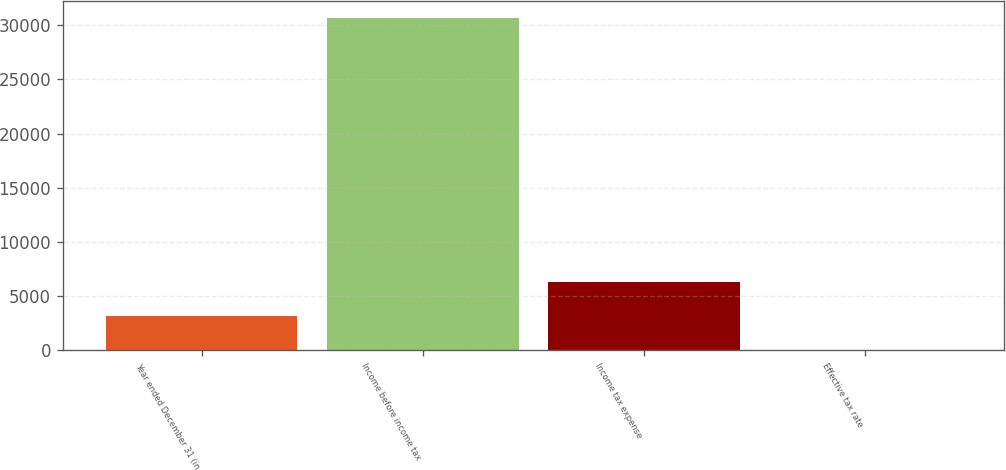Convert chart to OTSL. <chart><loc_0><loc_0><loc_500><loc_500><bar_chart><fcel>Year ended December 31 (in<fcel>Income before income tax<fcel>Income tax expense<fcel>Effective tax rate<nl><fcel>3088.56<fcel>30702<fcel>6260<fcel>20.4<nl></chart> 